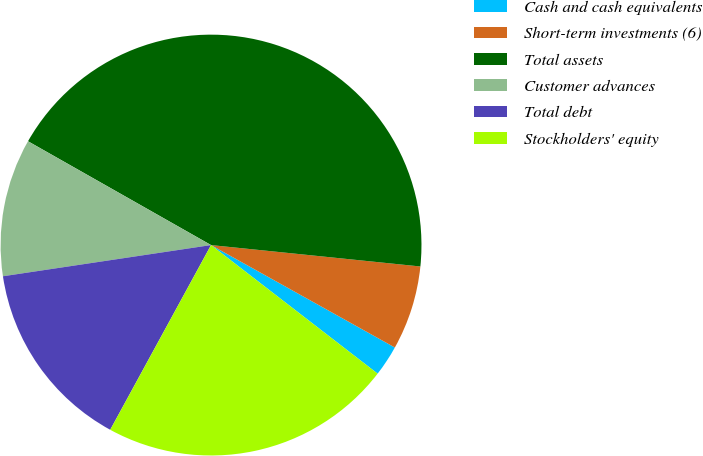Convert chart to OTSL. <chart><loc_0><loc_0><loc_500><loc_500><pie_chart><fcel>Cash and cash equivalents<fcel>Short-term investments (6)<fcel>Total assets<fcel>Customer advances<fcel>Total debt<fcel>Stockholders' equity<nl><fcel>2.37%<fcel>6.47%<fcel>43.41%<fcel>10.58%<fcel>14.68%<fcel>22.49%<nl></chart> 